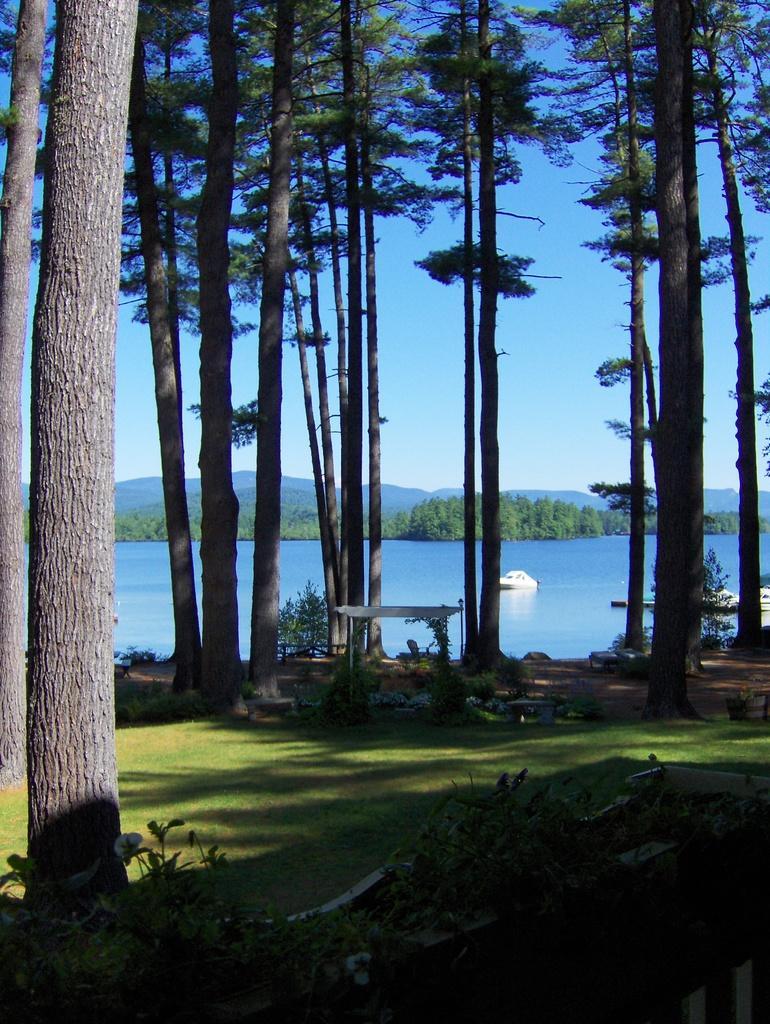Please provide a concise description of this image. We can see plants,grass and trees. In the background we can see trees, ships above the water and sky. 